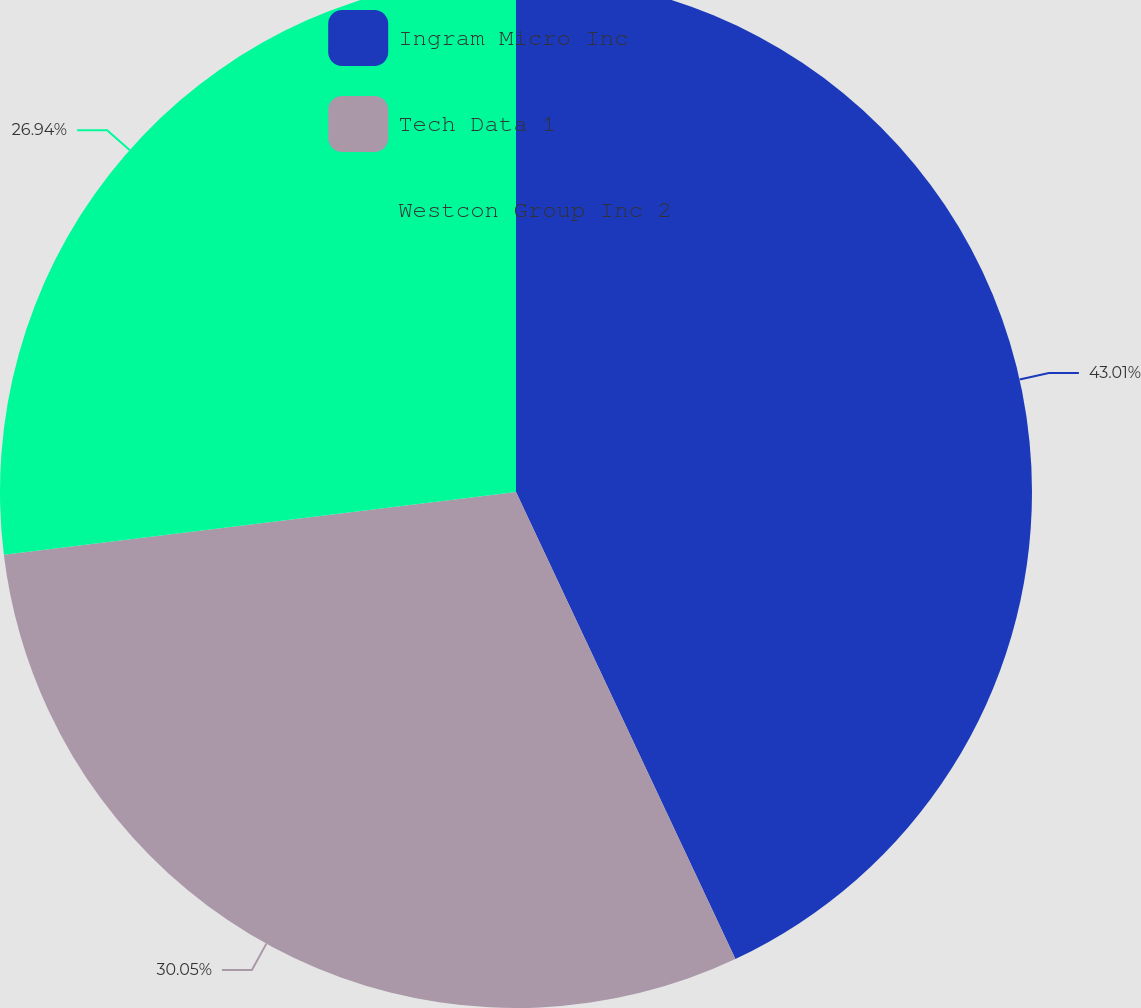Convert chart to OTSL. <chart><loc_0><loc_0><loc_500><loc_500><pie_chart><fcel>Ingram Micro Inc<fcel>Tech Data 1<fcel>Westcon Group Inc 2<nl><fcel>43.01%<fcel>30.05%<fcel>26.94%<nl></chart> 